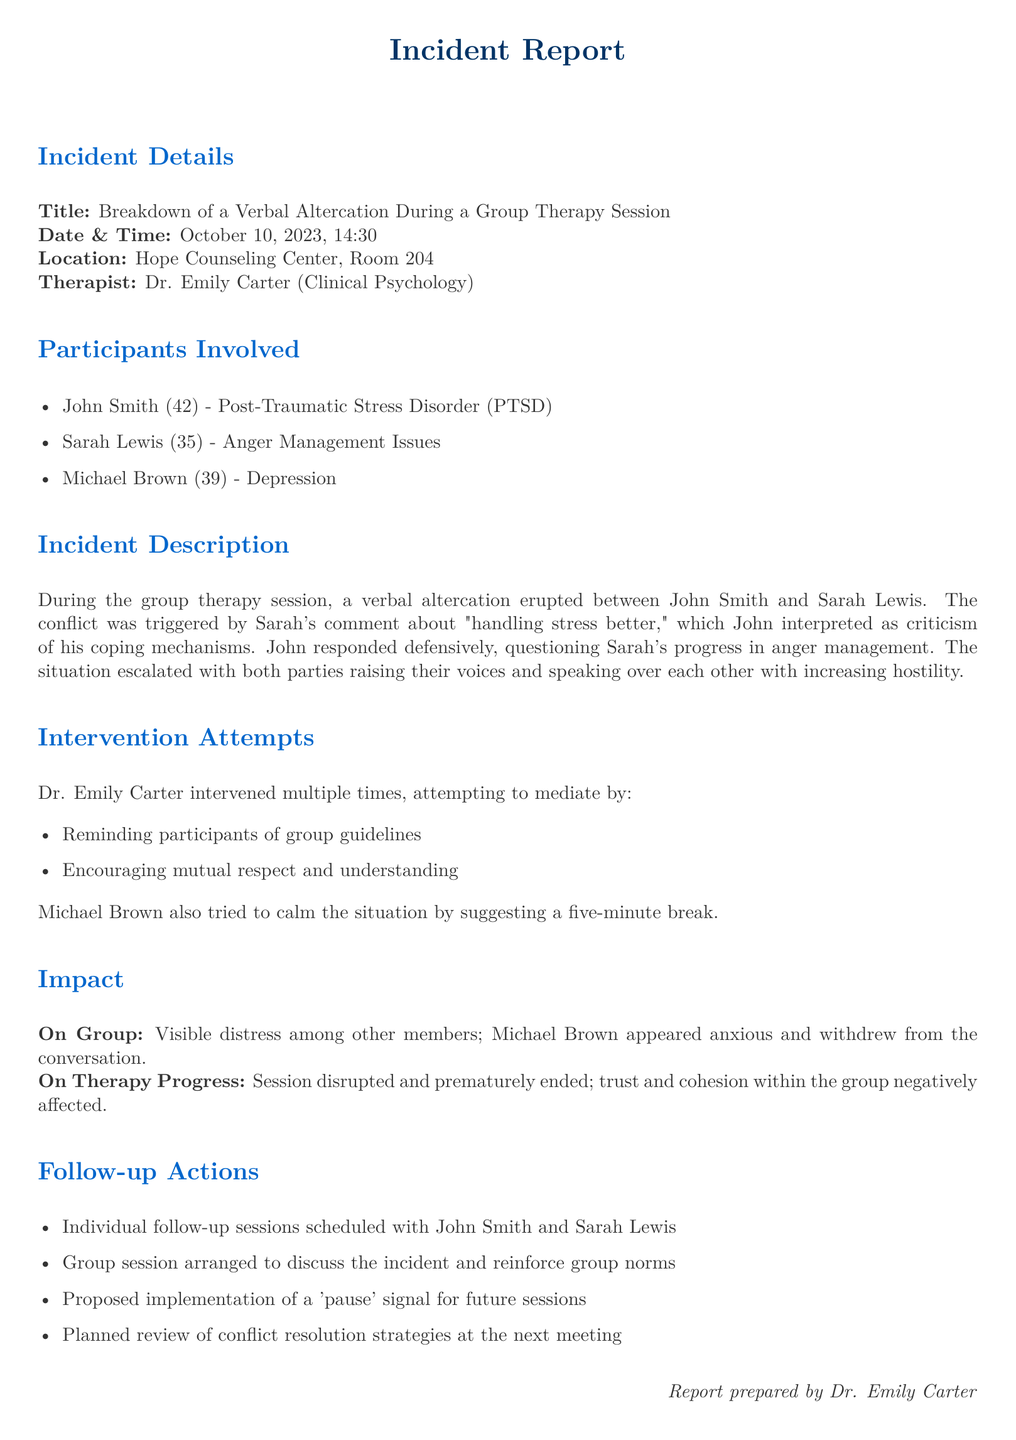What is the title of the incident report? The title is explicitly stated at the beginning of the incident report as "Breakdown of a Verbal Altercation During a Group Therapy Session."
Answer: Breakdown of a Verbal Altercation During a Group Therapy Session Who is the therapist conducting the session? The therapist's name is mentioned under the "Therapist" section as Dr. Emily Carter.
Answer: Dr. Emily Carter What was the date of the incident? The date of the incident is provided in the incident details section as October 10, 2023.
Answer: October 10, 2023 How did the incident impact the group? The document mentions visible distress among members and a negative effect on trust and cohesion within the group.
Answer: Visible distress among other members; trust and cohesion negatively affected What action was proposed for future sessions? The proposal for future sessions states the implementation of a 'pause' signal to manage conflicts.
Answer: Implementation of a 'pause' signal Which participant has Anger Management Issues? The participants' conditions are listed in the "Participants Involved" section, identifying Sarah Lewis with Anger Management Issues.
Answer: Sarah Lewis How was the situation initially escalated? The escalation began with a comment from Sarah about "handling stress better," interpreted by John as criticism, leading to defensiveness.
Answer: Sarah's comment about "handling stress better" What was Michael Brown's response during the incident? The response from Michael Brown was an attempt to calm the situation by suggesting a five-minute break.
Answer: Suggesting a five-minute break 